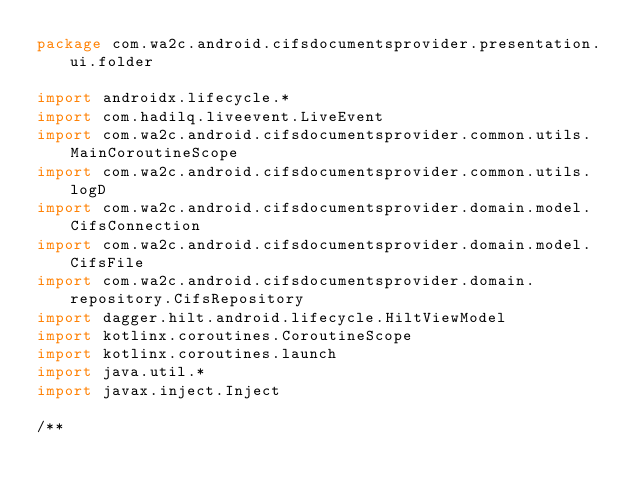Convert code to text. <code><loc_0><loc_0><loc_500><loc_500><_Kotlin_>package com.wa2c.android.cifsdocumentsprovider.presentation.ui.folder

import androidx.lifecycle.*
import com.hadilq.liveevent.LiveEvent
import com.wa2c.android.cifsdocumentsprovider.common.utils.MainCoroutineScope
import com.wa2c.android.cifsdocumentsprovider.common.utils.logD
import com.wa2c.android.cifsdocumentsprovider.domain.model.CifsConnection
import com.wa2c.android.cifsdocumentsprovider.domain.model.CifsFile
import com.wa2c.android.cifsdocumentsprovider.domain.repository.CifsRepository
import dagger.hilt.android.lifecycle.HiltViewModel
import kotlinx.coroutines.CoroutineScope
import kotlinx.coroutines.launch
import java.util.*
import javax.inject.Inject

/**</code> 